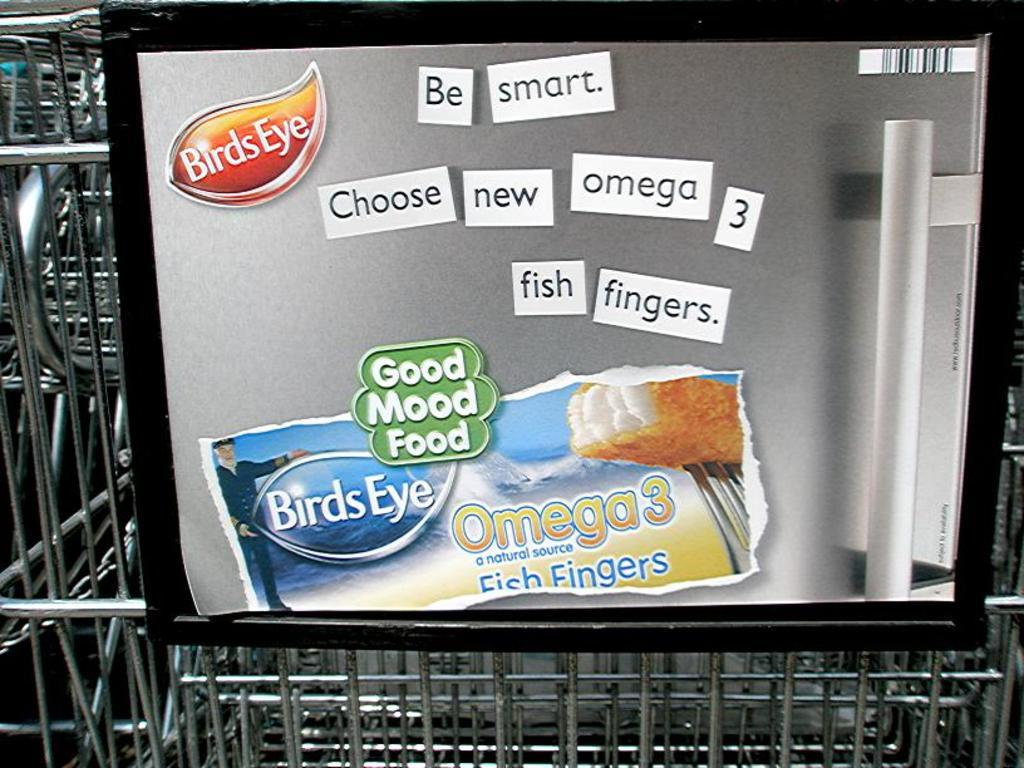<image>
Relay a brief, clear account of the picture shown. A add for birds eye fish fingers that says be smart choose new omega 3 fish fingers 